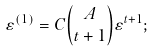<formula> <loc_0><loc_0><loc_500><loc_500>\varepsilon ^ { ( 1 ) } = C { A \choose t + 1 } \varepsilon ^ { t + 1 } ;</formula> 